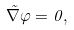<formula> <loc_0><loc_0><loc_500><loc_500>\vec { \nabla } \varphi = 0 ,</formula> 